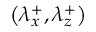Convert formula to latex. <formula><loc_0><loc_0><loc_500><loc_500>\left ( { \lambda } _ { x } ^ { + } , { \lambda } _ { z } ^ { + } \right )</formula> 